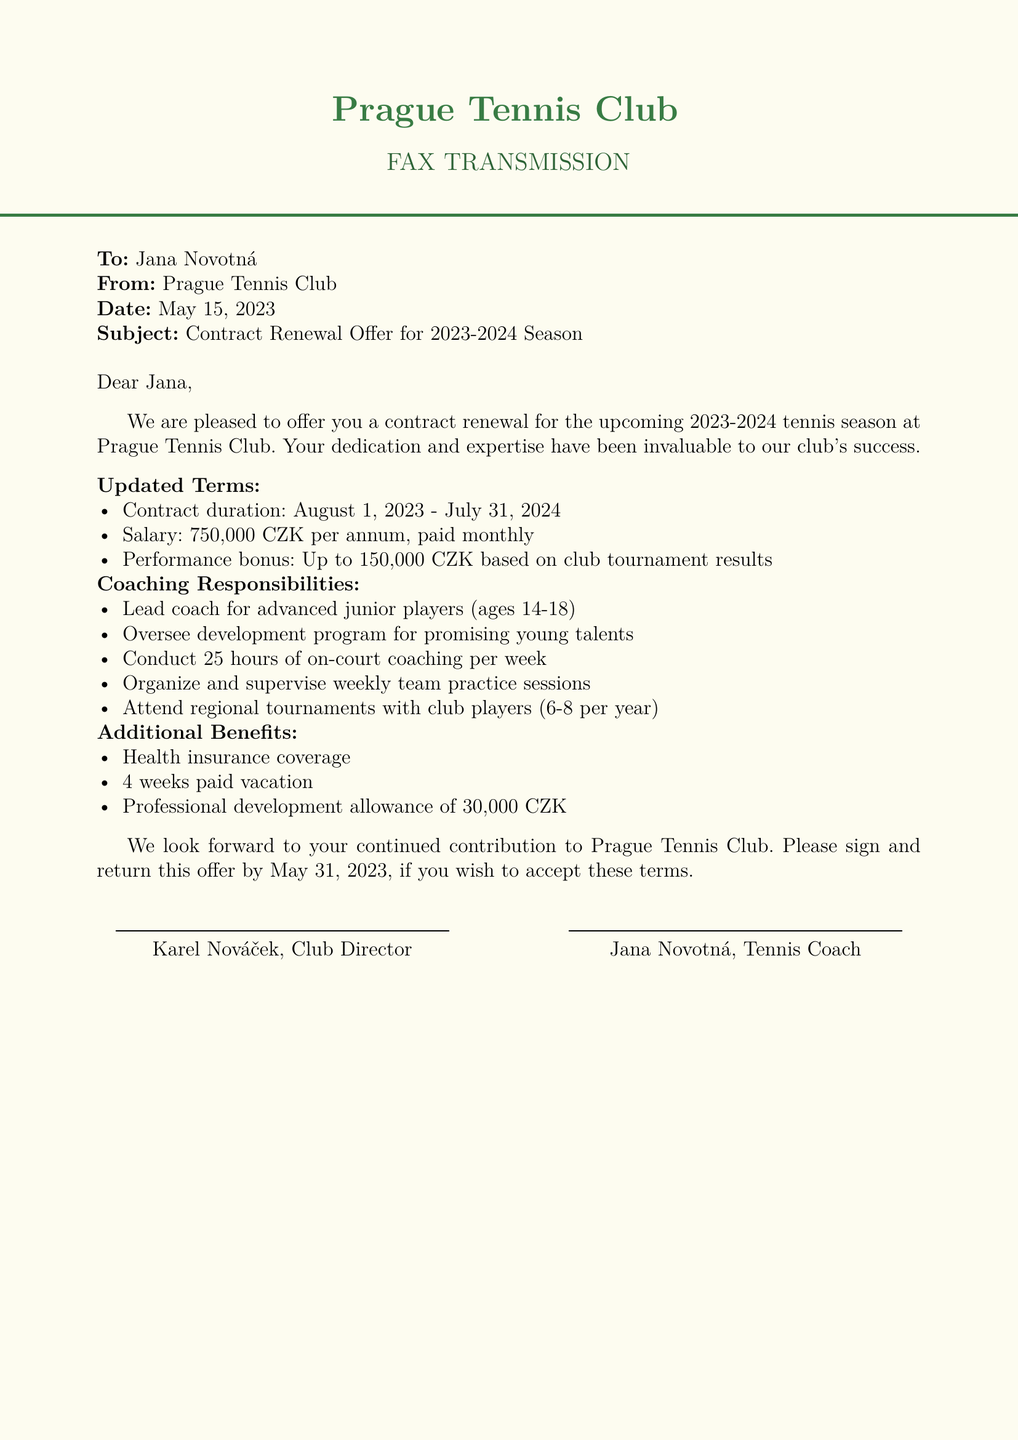What is the contract duration? The duration of the contract is stated in the document, which is from August 1, 2023, to July 31, 2024.
Answer: August 1, 2023 - July 31, 2024 What is the annual salary offered? The document specifies the salary to be paid per annum.
Answer: 750,000 CZK What is the performance bonus based on? The bonus mentioned is tied to the outcomes of club tournaments.
Answer: Club tournament results How many hours of on-court coaching are required per week? The document outlines the weekly coaching hours expected from the coach.
Answer: 25 hours Who is the sender of the fax? The name of the organization sending the fax is provided at the top of the document.
Answer: Prague Tennis Club How many regional tournaments is the coach expected to attend each year? The number of tournaments the coach will attend is mentioned in the document.
Answer: 6-8 per year What is included in the additional benefits? The document lists various benefits provided to the coach, one of which is health insurance coverage.
Answer: Health insurance coverage What is the deadline to accept the offer? The deadline to sign and return the offer is specified in the document.
Answer: May 31, 2023 